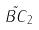Convert formula to latex. <formula><loc_0><loc_0><loc_500><loc_500>\tilde { B C } _ { 2 }</formula> 